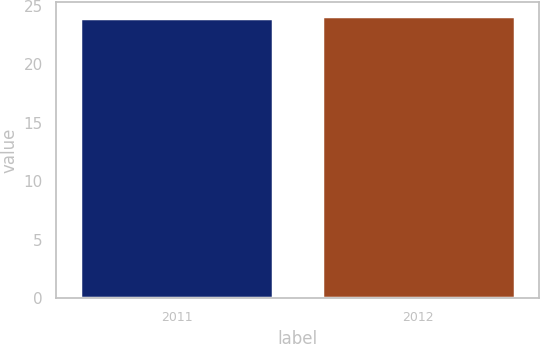<chart> <loc_0><loc_0><loc_500><loc_500><bar_chart><fcel>2011<fcel>2012<nl><fcel>24<fcel>24.1<nl></chart> 